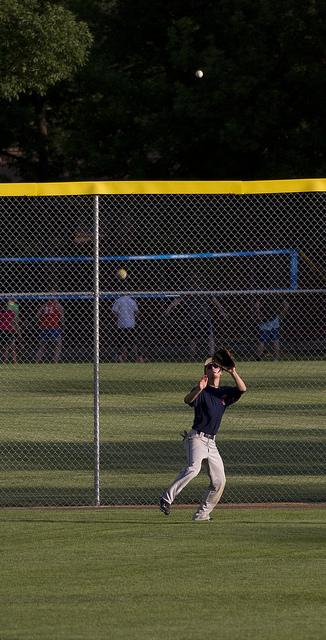What position is this player playing?

Choices:
A) pitcher
B) outfielder
C) catcher
D) 1st base outfielder 